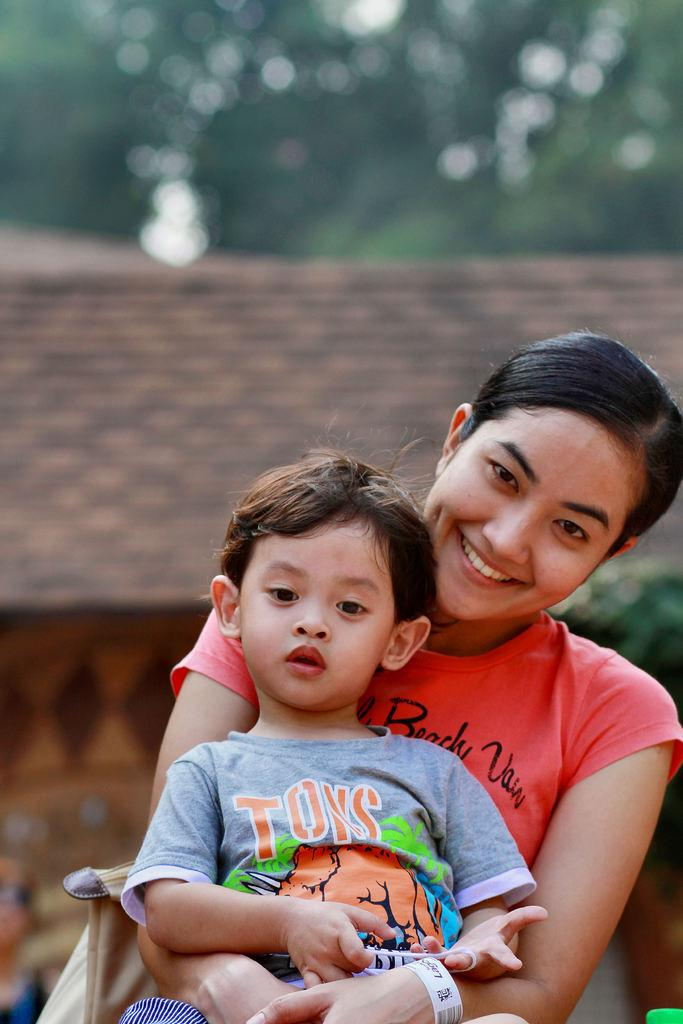How many people are present in the image? There are two people in the image. What colors are the people's clothing? The people are wearing ash-colored and peach-colored clothing. What can be seen in the background of the image? There are trees and a house in the background of the image. What type of vein is visible on the tree in the image? There is no vein visible on the tree in the image, as veins are a part of living organisms and not present in trees. 